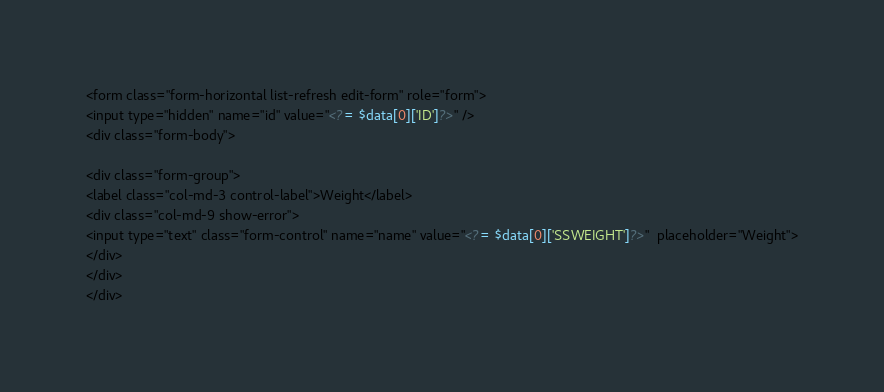Convert code to text. <code><loc_0><loc_0><loc_500><loc_500><_PHP_><form class="form-horizontal list-refresh edit-form" role="form">
<input type="hidden" name="id" value="<?= $data[0]['ID']?>" />
<div class="form-body">

<div class="form-group">
<label class="col-md-3 control-label">Weight</label>
<div class="col-md-9 show-error">
<input type="text" class="form-control" name="name" value="<?= $data[0]['SSWEIGHT']?>"  placeholder="Weight">
</div>
</div>
</div></code> 